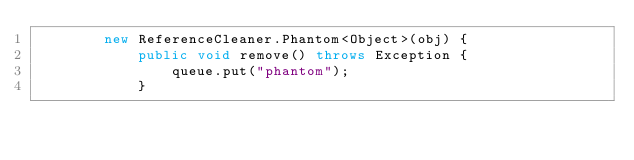Convert code to text. <code><loc_0><loc_0><loc_500><loc_500><_Java_>        new ReferenceCleaner.Phantom<Object>(obj) {
            public void remove() throws Exception {
                queue.put("phantom");
            }</code> 